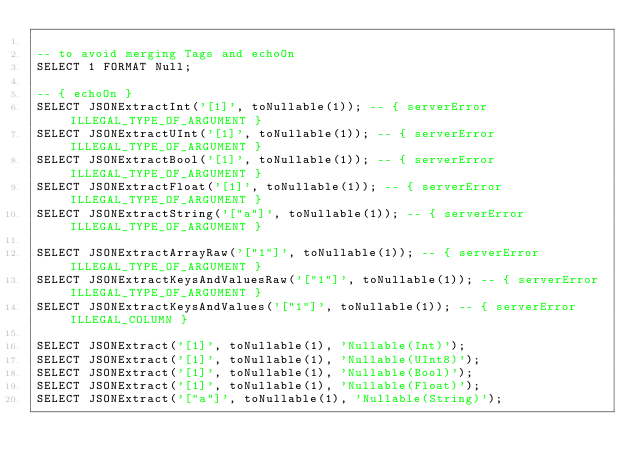Convert code to text. <code><loc_0><loc_0><loc_500><loc_500><_SQL_>
-- to avoid merging Tags and echoOn
SELECT 1 FORMAT Null;

-- { echoOn }
SELECT JSONExtractInt('[1]', toNullable(1)); -- { serverError ILLEGAL_TYPE_OF_ARGUMENT }
SELECT JSONExtractUInt('[1]', toNullable(1)); -- { serverError ILLEGAL_TYPE_OF_ARGUMENT }
SELECT JSONExtractBool('[1]', toNullable(1)); -- { serverError ILLEGAL_TYPE_OF_ARGUMENT }
SELECT JSONExtractFloat('[1]', toNullable(1)); -- { serverError ILLEGAL_TYPE_OF_ARGUMENT }
SELECT JSONExtractString('["a"]', toNullable(1)); -- { serverError ILLEGAL_TYPE_OF_ARGUMENT }

SELECT JSONExtractArrayRaw('["1"]', toNullable(1)); -- { serverError ILLEGAL_TYPE_OF_ARGUMENT }
SELECT JSONExtractKeysAndValuesRaw('["1"]', toNullable(1)); -- { serverError ILLEGAL_TYPE_OF_ARGUMENT }
SELECT JSONExtractKeysAndValues('["1"]', toNullable(1)); -- { serverError ILLEGAL_COLUMN }

SELECT JSONExtract('[1]', toNullable(1), 'Nullable(Int)');
SELECT JSONExtract('[1]', toNullable(1), 'Nullable(UInt8)');
SELECT JSONExtract('[1]', toNullable(1), 'Nullable(Bool)');
SELECT JSONExtract('[1]', toNullable(1), 'Nullable(Float)');
SELECT JSONExtract('["a"]', toNullable(1), 'Nullable(String)');
</code> 